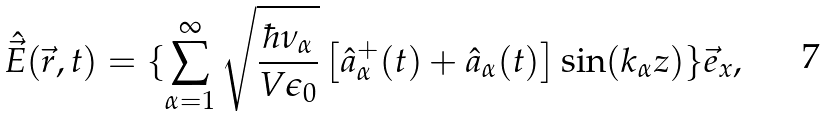<formula> <loc_0><loc_0><loc_500><loc_500>\hat { \vec { E } } ( \vec { r } , t ) = \{ \sum _ { \alpha = 1 } ^ { \infty } \sqrt { \frac { \hbar { \nu } _ { \alpha } } { V \epsilon _ { 0 } } } \left [ \hat { a } ^ { + } _ { \alpha } ( t ) + \hat { a } _ { \alpha } ( t ) \right ] \sin ( k _ { \alpha } z ) \} \vec { e } _ { x } ,</formula> 